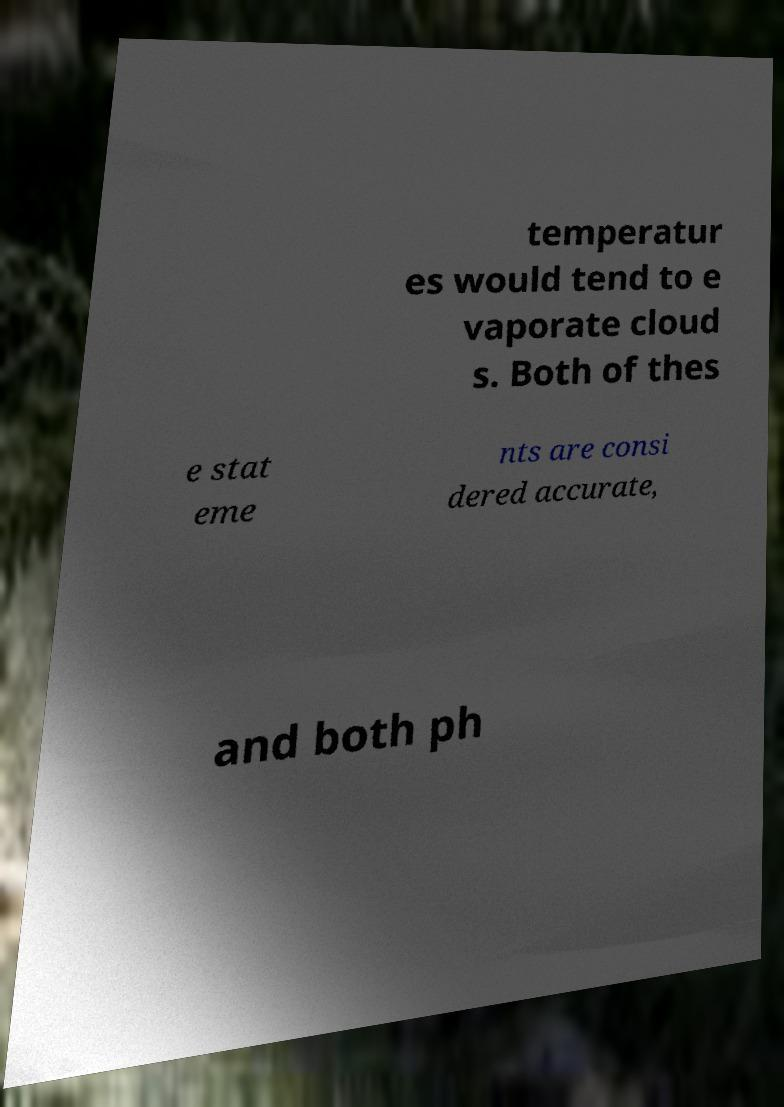There's text embedded in this image that I need extracted. Can you transcribe it verbatim? temperatur es would tend to e vaporate cloud s. Both of thes e stat eme nts are consi dered accurate, and both ph 